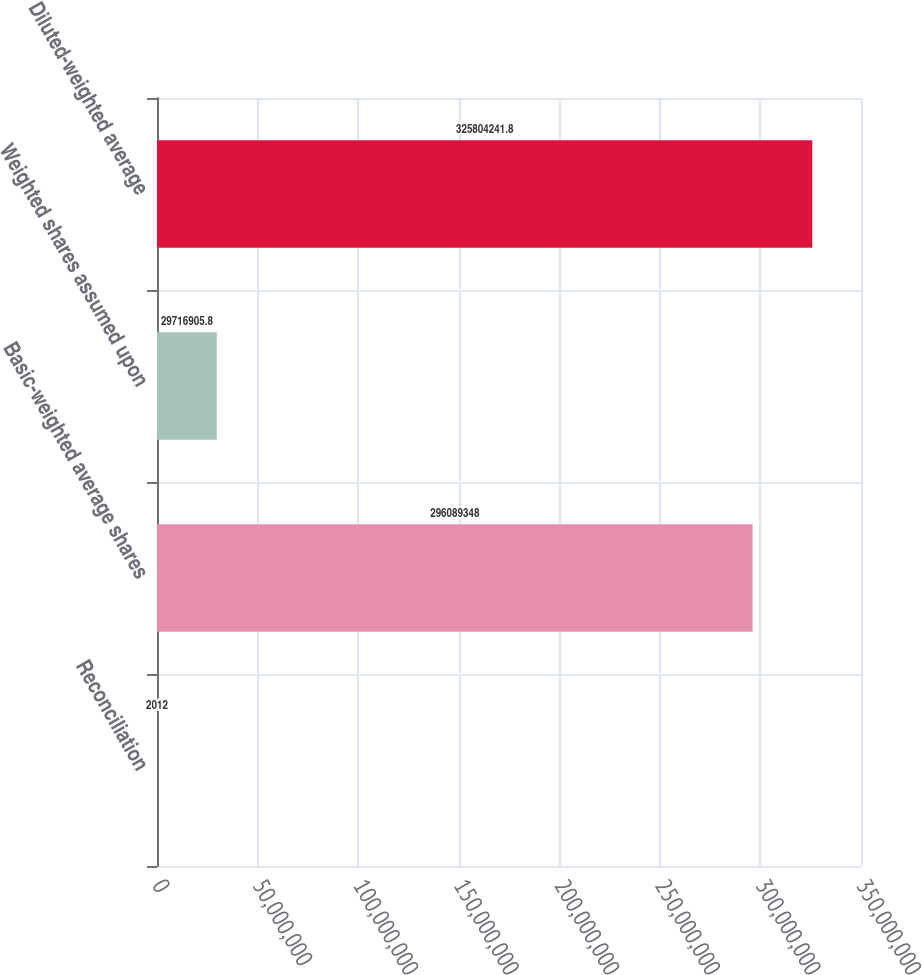Convert chart. <chart><loc_0><loc_0><loc_500><loc_500><bar_chart><fcel>Reconciliation<fcel>Basic-weighted average shares<fcel>Weighted shares assumed upon<fcel>Diluted-weighted average<nl><fcel>2012<fcel>2.96089e+08<fcel>2.97169e+07<fcel>3.25804e+08<nl></chart> 